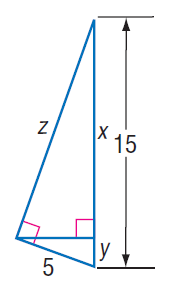Question: Find y.
Choices:
A. \frac { 3 } { 5 }
B. \frac { 5 } { 3 }
C. \frac { 5 } { \sqrt { 3 } }
D. 5
Answer with the letter. Answer: B Question: Find z.
Choices:
A. 2
B. 3
C. 10
D. 10 \sqrt { 2 }
Answer with the letter. Answer: D 